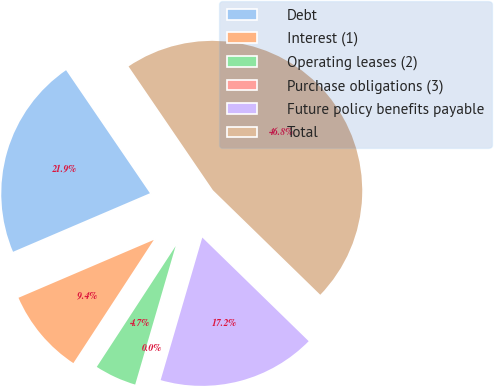Convert chart. <chart><loc_0><loc_0><loc_500><loc_500><pie_chart><fcel>Debt<fcel>Interest (1)<fcel>Operating leases (2)<fcel>Purchase obligations (3)<fcel>Future policy benefits payable<fcel>Total<nl><fcel>21.91%<fcel>9.36%<fcel>4.68%<fcel>0.0%<fcel>17.23%<fcel>46.81%<nl></chart> 